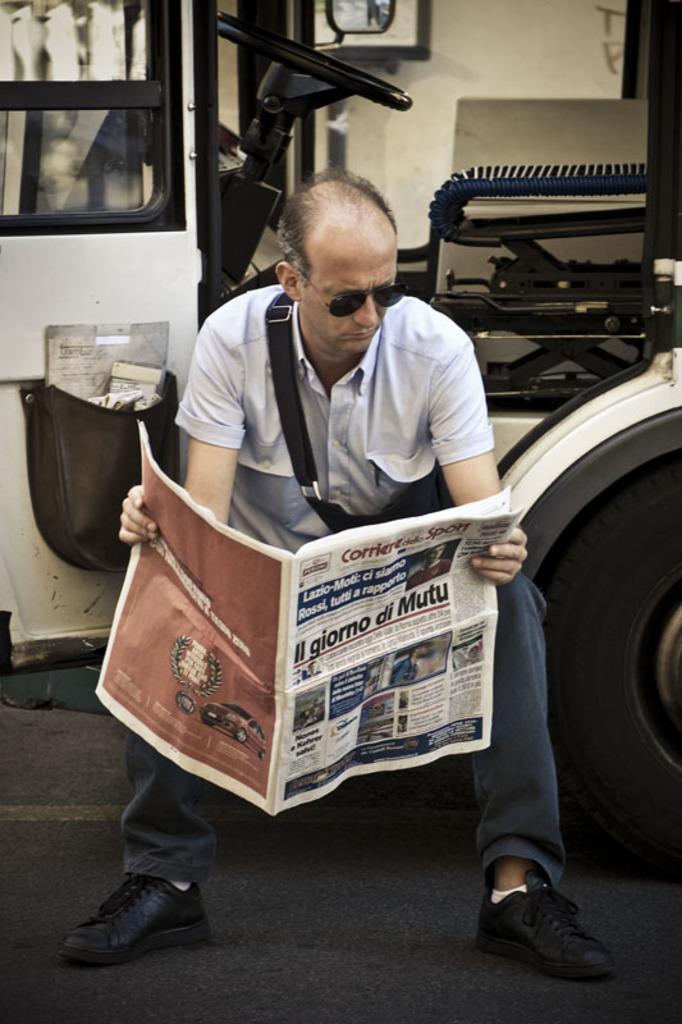In one or two sentences, can you explain what this image depicts? In this image we can see a person wearing goggles is holding a newspaper in his hands. In the background, we can see a vehicle parked on road , a steering wheel, seat, mirror and a door. 